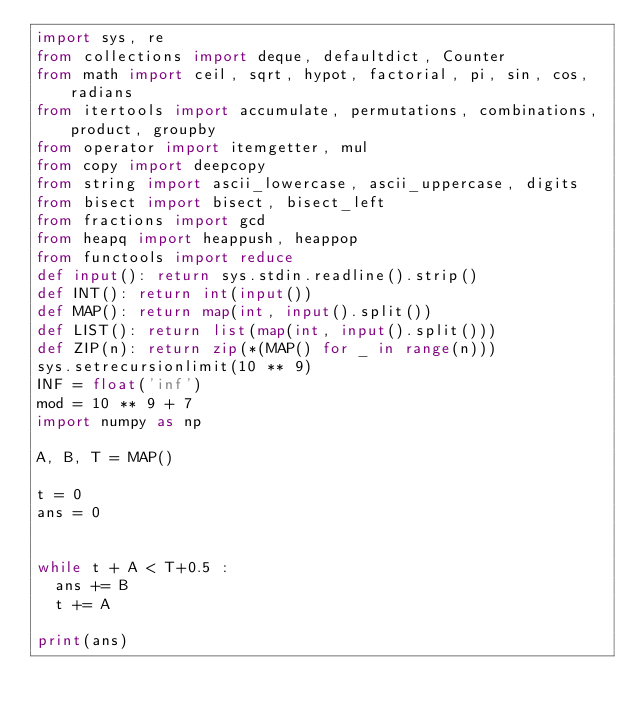Convert code to text. <code><loc_0><loc_0><loc_500><loc_500><_Python_>import sys, re
from collections import deque, defaultdict, Counter
from math import ceil, sqrt, hypot, factorial, pi, sin, cos, radians
from itertools import accumulate, permutations, combinations, product, groupby
from operator import itemgetter, mul
from copy import deepcopy
from string import ascii_lowercase, ascii_uppercase, digits
from bisect import bisect, bisect_left
from fractions import gcd
from heapq import heappush, heappop
from functools import reduce
def input(): return sys.stdin.readline().strip()
def INT(): return int(input())
def MAP(): return map(int, input().split())
def LIST(): return list(map(int, input().split()))
def ZIP(n): return zip(*(MAP() for _ in range(n)))
sys.setrecursionlimit(10 ** 9)
INF = float('inf')
mod = 10 ** 9 + 7
import numpy as np

A, B, T = MAP()

t = 0
ans = 0


while t + A < T+0.5 :
	ans += B
	t += A

print(ans)</code> 